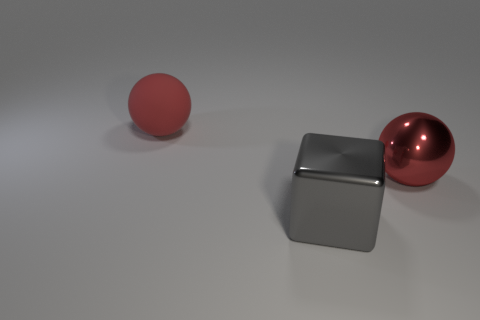Add 1 large red matte balls. How many objects exist? 4 Subtract all blocks. How many objects are left? 2 Add 2 tiny matte blocks. How many tiny matte blocks exist? 2 Subtract 2 red spheres. How many objects are left? 1 Subtract all red matte balls. Subtract all big red shiny balls. How many objects are left? 1 Add 1 big red things. How many big red things are left? 3 